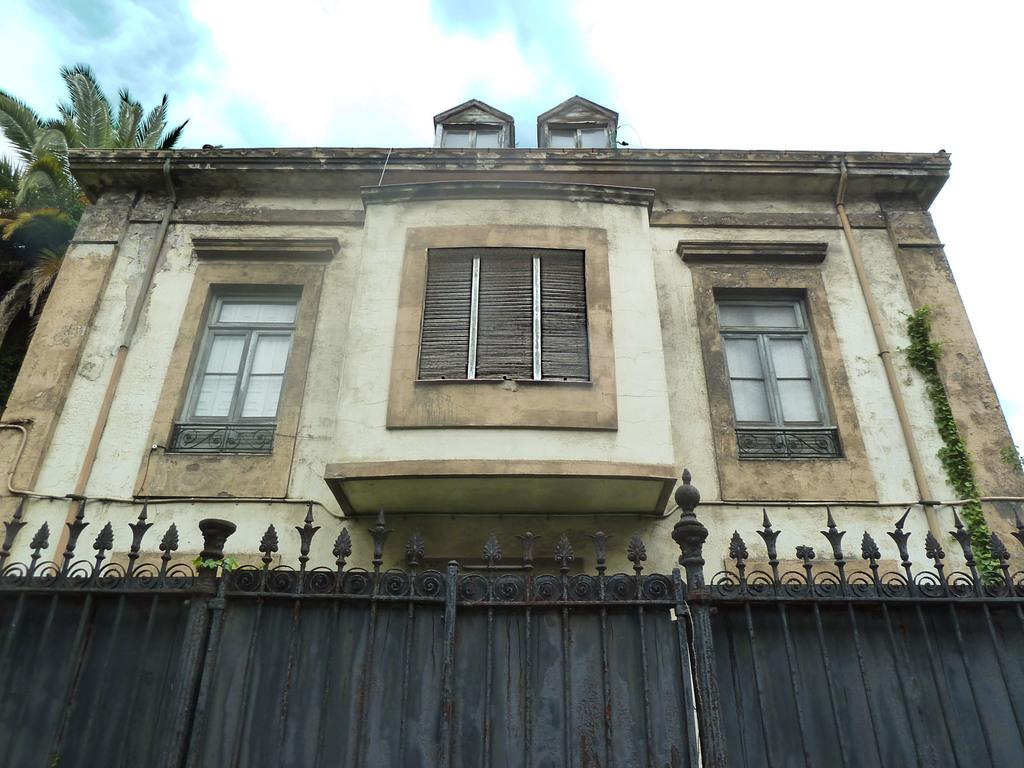What is the main subject of the image? The main subject of the image is the front view of a building. What features can be seen on the building? The building has windows. What is located near the building in the image? There is a fence in the image. What type of vegetation is on the left side of the image? There is a tree on the left side of the image. What is visible at the top of the image? The sky is visible at the top of the image. What can be observed in the sky? Clouds are present in the sky. How many bees can be seen on the scale in the image? There are no bees or scales present in the image. What type of store is located on the right side of the image? There is no store visible in the image; it shows the front view of a building with a tree and a fence. 